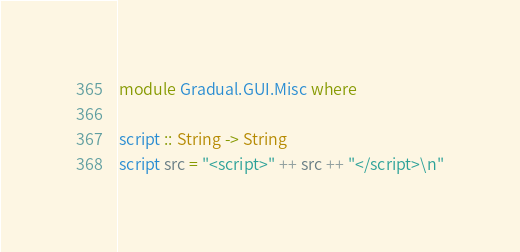Convert code to text. <code><loc_0><loc_0><loc_500><loc_500><_Haskell_>module Gradual.GUI.Misc where 

script :: String -> String
script src = "<script>" ++ src ++ "</script>\n"
</code> 